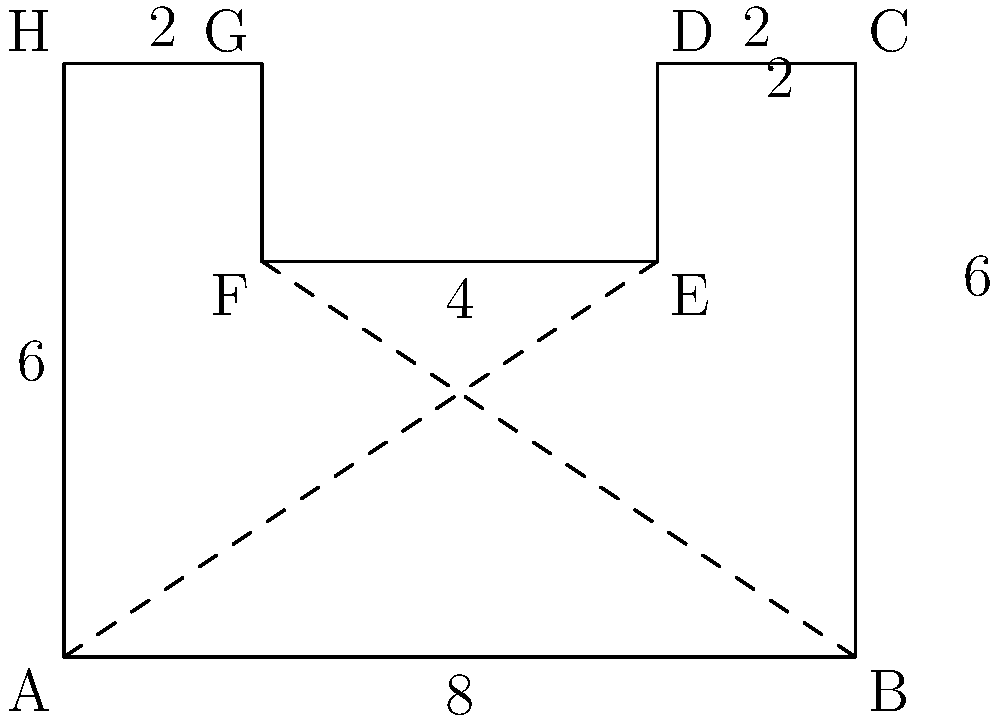In your research on Renaissance garden layouts, you come across an irregular octagonal garden design. The garden's dimensions are given in the diagram (in meters). Calculate the total area of this Renaissance garden. To calculate the area of this irregular octagon, we can divide it into simpler shapes and sum their areas:

1. Divide the octagon into a rectangle and two trapezoids.

2. Calculate the area of the main rectangle (ABEF):
   $A_{rectangle} = 8 \times 4 = 32$ m²

3. Calculate the area of the upper trapezoid (DCEF):
   $A_{upper} = \frac{1}{2}(2 + 6) \times 2 = 8$ m²

4. Calculate the area of the lower trapezoid (AHGF):
   $A_{lower} = \frac{1}{2}(6 + 2) \times 2 = 8$ m²

5. Sum all areas:
   $A_{total} = A_{rectangle} + A_{upper} + A_{lower}$
   $A_{total} = 32 + 8 + 8 = 48$ m²

Therefore, the total area of the Renaissance garden is 48 square meters.
Answer: 48 m² 